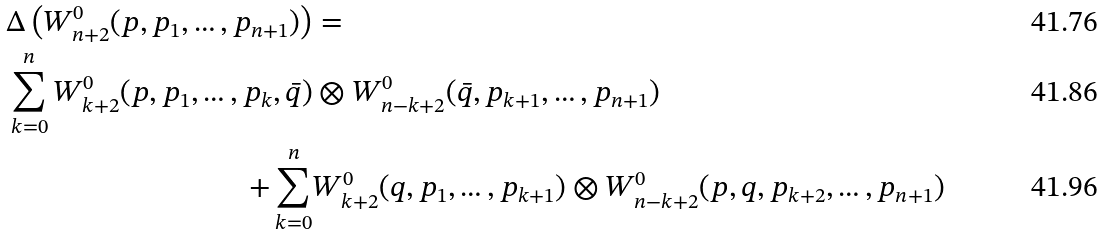<formula> <loc_0><loc_0><loc_500><loc_500>\Delta \left ( W ^ { 0 } _ { n + 2 } ( p , p _ { 1 } , \dots , p _ { n + 1 } ) \right ) & = \\ \sum _ { k = 0 } ^ { n } W ^ { 0 } _ { k + 2 } ( p , p _ { 1 } , \dots , p _ { k } , \bar { q } ) & \otimes W ^ { 0 } _ { n - k + 2 } ( \bar { q } , p _ { k + 1 } , \dots , p _ { n + 1 } ) \\ + \sum _ { k = 0 } ^ { n } & W ^ { 0 } _ { k + 2 } ( q , p _ { 1 } , \dots , p _ { k + 1 } ) \otimes W ^ { 0 } _ { n - k + 2 } ( p , q , p _ { k + 2 } , \dots , p _ { n + 1 } )</formula> 